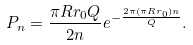Convert formula to latex. <formula><loc_0><loc_0><loc_500><loc_500>P _ { n } = \frac { \pi R r _ { 0 } Q } { 2 n } e ^ { - \frac { 2 \pi ( \pi R r _ { 0 } ) n } { Q } } .</formula> 